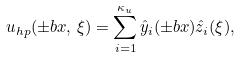Convert formula to latex. <formula><loc_0><loc_0><loc_500><loc_500>u _ { h p } ( \pm b { x } , \, \xi ) = \sum _ { i = 1 } ^ { \kappa _ { u } } \hat { y } _ { i } ( \pm b { x } ) \hat { z } _ { i } ( \xi ) ,</formula> 